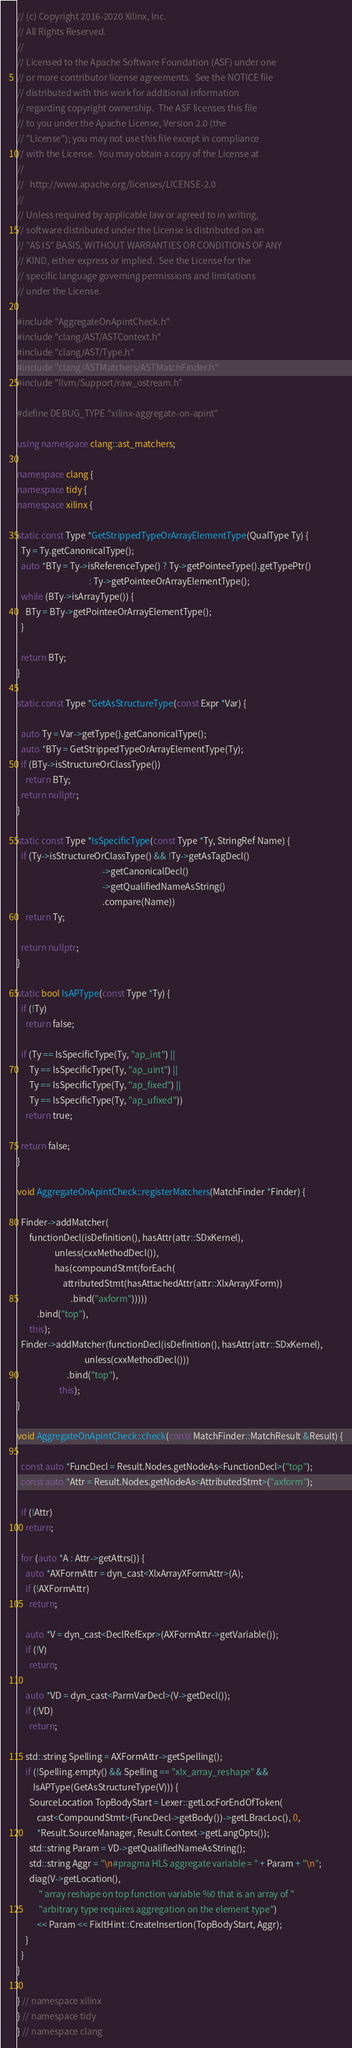<code> <loc_0><loc_0><loc_500><loc_500><_C++_>// (c) Copyright 2016-2020 Xilinx, Inc.
// All Rights Reserved.
//
// Licensed to the Apache Software Foundation (ASF) under one
// or more contributor license agreements.  See the NOTICE file
// distributed with this work for additional information
// regarding copyright ownership.  The ASF licenses this file
// to you under the Apache License, Version 2.0 (the
// "License"); you may not use this file except in compliance
// with the License.  You may obtain a copy of the License at
//
//   http://www.apache.org/licenses/LICENSE-2.0
//
// Unless required by applicable law or agreed to in writing,
// software distributed under the License is distributed on an
// "AS IS" BASIS, WITHOUT WARRANTIES OR CONDITIONS OF ANY
// KIND, either express or implied.  See the License for the
// specific language governing permissions and limitations
// under the License.

#include "AggregateOnApintCheck.h"
#include "clang/AST/ASTContext.h"
#include "clang/AST/Type.h"
#include "clang/ASTMatchers/ASTMatchFinder.h"
#include "llvm/Support/raw_ostream.h"

#define DEBUG_TYPE "xilinx-aggregate-on-apint"

using namespace clang::ast_matchers;

namespace clang {
namespace tidy {
namespace xilinx {

static const Type *GetStrippedTypeOrArrayElementType(QualType Ty) {
  Ty = Ty.getCanonicalType();
  auto *BTy = Ty->isReferenceType() ? Ty->getPointeeType().getTypePtr()
                                    : Ty->getPointeeOrArrayElementType();
  while (BTy->isArrayType()) {
    BTy = BTy->getPointeeOrArrayElementType();
  }

  return BTy;
}

static const Type *GetAsStructureType(const Expr *Var) {

  auto Ty = Var->getType().getCanonicalType();
  auto *BTy = GetStrippedTypeOrArrayElementType(Ty);
  if (BTy->isStructureOrClassType())
    return BTy;
  return nullptr;
}

static const Type *IsSpecificType(const Type *Ty, StringRef Name) {
  if (Ty->isStructureOrClassType() && !Ty->getAsTagDecl()
                                           ->getCanonicalDecl()
                                           ->getQualifiedNameAsString()
                                           .compare(Name))
    return Ty;

  return nullptr;
}

static bool IsAPType(const Type *Ty) {
  if (!Ty)
    return false;

  if (Ty == IsSpecificType(Ty, "ap_int") ||
      Ty == IsSpecificType(Ty, "ap_uint") ||
      Ty == IsSpecificType(Ty, "ap_fixed") ||
      Ty == IsSpecificType(Ty, "ap_ufixed"))
    return true;

  return false;
}

void AggregateOnApintCheck::registerMatchers(MatchFinder *Finder) {

  Finder->addMatcher(
      functionDecl(isDefinition(), hasAttr(attr::SDxKernel),
                   unless(cxxMethodDecl()),
                   has(compoundStmt(forEach(
                       attributedStmt(hasAttachedAttr(attr::XlxArrayXForm))
                           .bind("axform")))))
          .bind("top"),
      this);
  Finder->addMatcher(functionDecl(isDefinition(), hasAttr(attr::SDxKernel),
                                  unless(cxxMethodDecl()))
                         .bind("top"),
                     this);
}

void AggregateOnApintCheck::check(const MatchFinder::MatchResult &Result) {

  const auto *FuncDecl = Result.Nodes.getNodeAs<FunctionDecl>("top");
  const auto *Attr = Result.Nodes.getNodeAs<AttributedStmt>("axform");

  if (!Attr)
    return;

  for (auto *A : Attr->getAttrs()) {
    auto *AXFormAttr = dyn_cast<XlxArrayXFormAttr>(A);
    if (!AXFormAttr)
      return;

    auto *V = dyn_cast<DeclRefExpr>(AXFormAttr->getVariable());
    if (!V)
      return;

    auto *VD = dyn_cast<ParmVarDecl>(V->getDecl());
    if (!VD)
      return;

    std::string Spelling = AXFormAttr->getSpelling();
    if (!Spelling.empty() && Spelling == "xlx_array_reshape" &&
        IsAPType(GetAsStructureType(V))) {
      SourceLocation TopBodyStart = Lexer::getLocForEndOfToken(
          cast<CompoundStmt>(FuncDecl->getBody())->getLBracLoc(), 0,
          *Result.SourceManager, Result.Context->getLangOpts());
      std::string Param = VD->getQualifiedNameAsString();
      std::string Aggr = "\n#pragma HLS aggregate variable = " + Param + "\n";
      diag(V->getLocation(),
           " array reshape on top function variable %0 that is an array of "
           "arbitrary type requires aggregation on the element type")
          << Param << FixItHint::CreateInsertion(TopBodyStart, Aggr);
    }
  }
}

} // namespace xilinx
} // namespace tidy
} // namespace clang
</code> 